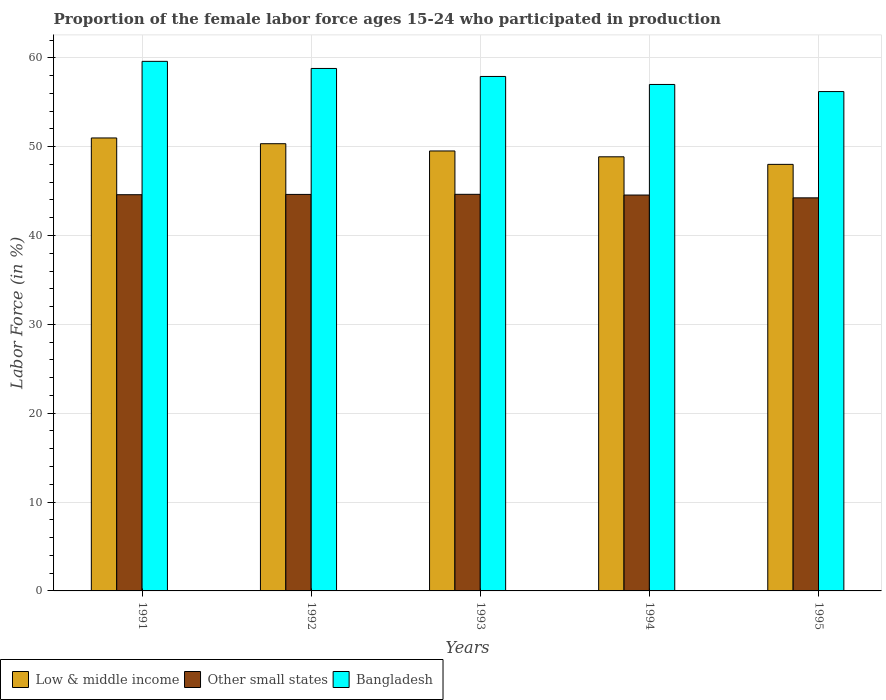How many different coloured bars are there?
Your response must be concise. 3. How many groups of bars are there?
Keep it short and to the point. 5. Are the number of bars per tick equal to the number of legend labels?
Make the answer very short. Yes. What is the label of the 3rd group of bars from the left?
Your response must be concise. 1993. What is the proportion of the female labor force who participated in production in Low & middle income in 1995?
Provide a short and direct response. 48.01. Across all years, what is the maximum proportion of the female labor force who participated in production in Low & middle income?
Provide a short and direct response. 50.98. Across all years, what is the minimum proportion of the female labor force who participated in production in Bangladesh?
Give a very brief answer. 56.2. In which year was the proportion of the female labor force who participated in production in Low & middle income minimum?
Offer a terse response. 1995. What is the total proportion of the female labor force who participated in production in Low & middle income in the graph?
Your answer should be very brief. 247.69. What is the difference between the proportion of the female labor force who participated in production in Low & middle income in 1992 and that in 1995?
Offer a terse response. 2.32. What is the difference between the proportion of the female labor force who participated in production in Other small states in 1993 and the proportion of the female labor force who participated in production in Bangladesh in 1991?
Your answer should be compact. -14.97. What is the average proportion of the female labor force who participated in production in Other small states per year?
Keep it short and to the point. 44.53. In the year 1995, what is the difference between the proportion of the female labor force who participated in production in Bangladesh and proportion of the female labor force who participated in production in Other small states?
Make the answer very short. 11.96. In how many years, is the proportion of the female labor force who participated in production in Bangladesh greater than 12 %?
Give a very brief answer. 5. What is the ratio of the proportion of the female labor force who participated in production in Bangladesh in 1992 to that in 1994?
Your answer should be very brief. 1.03. Is the proportion of the female labor force who participated in production in Other small states in 1992 less than that in 1993?
Your answer should be compact. Yes. Is the difference between the proportion of the female labor force who participated in production in Bangladesh in 1991 and 1995 greater than the difference between the proportion of the female labor force who participated in production in Other small states in 1991 and 1995?
Make the answer very short. Yes. What is the difference between the highest and the second highest proportion of the female labor force who participated in production in Bangladesh?
Provide a succinct answer. 0.8. What is the difference between the highest and the lowest proportion of the female labor force who participated in production in Low & middle income?
Give a very brief answer. 2.97. In how many years, is the proportion of the female labor force who participated in production in Other small states greater than the average proportion of the female labor force who participated in production in Other small states taken over all years?
Offer a terse response. 4. Is the sum of the proportion of the female labor force who participated in production in Low & middle income in 1992 and 1995 greater than the maximum proportion of the female labor force who participated in production in Other small states across all years?
Provide a succinct answer. Yes. Is it the case that in every year, the sum of the proportion of the female labor force who participated in production in Other small states and proportion of the female labor force who participated in production in Bangladesh is greater than the proportion of the female labor force who participated in production in Low & middle income?
Your answer should be compact. Yes. How many years are there in the graph?
Ensure brevity in your answer.  5. What is the difference between two consecutive major ticks on the Y-axis?
Offer a terse response. 10. Does the graph contain any zero values?
Provide a succinct answer. No. Does the graph contain grids?
Provide a succinct answer. Yes. How many legend labels are there?
Provide a short and direct response. 3. What is the title of the graph?
Your answer should be compact. Proportion of the female labor force ages 15-24 who participated in production. Does "Brazil" appear as one of the legend labels in the graph?
Ensure brevity in your answer.  No. What is the Labor Force (in %) in Low & middle income in 1991?
Your answer should be compact. 50.98. What is the Labor Force (in %) in Other small states in 1991?
Offer a very short reply. 44.59. What is the Labor Force (in %) in Bangladesh in 1991?
Give a very brief answer. 59.6. What is the Labor Force (in %) of Low & middle income in 1992?
Your response must be concise. 50.33. What is the Labor Force (in %) in Other small states in 1992?
Your response must be concise. 44.62. What is the Labor Force (in %) of Bangladesh in 1992?
Give a very brief answer. 58.8. What is the Labor Force (in %) in Low & middle income in 1993?
Your answer should be compact. 49.51. What is the Labor Force (in %) in Other small states in 1993?
Your answer should be compact. 44.63. What is the Labor Force (in %) in Bangladesh in 1993?
Offer a very short reply. 57.9. What is the Labor Force (in %) of Low & middle income in 1994?
Give a very brief answer. 48.86. What is the Labor Force (in %) of Other small states in 1994?
Offer a very short reply. 44.55. What is the Labor Force (in %) in Bangladesh in 1994?
Provide a short and direct response. 57. What is the Labor Force (in %) in Low & middle income in 1995?
Provide a short and direct response. 48.01. What is the Labor Force (in %) of Other small states in 1995?
Make the answer very short. 44.24. What is the Labor Force (in %) of Bangladesh in 1995?
Offer a terse response. 56.2. Across all years, what is the maximum Labor Force (in %) of Low & middle income?
Keep it short and to the point. 50.98. Across all years, what is the maximum Labor Force (in %) in Other small states?
Give a very brief answer. 44.63. Across all years, what is the maximum Labor Force (in %) of Bangladesh?
Provide a succinct answer. 59.6. Across all years, what is the minimum Labor Force (in %) of Low & middle income?
Keep it short and to the point. 48.01. Across all years, what is the minimum Labor Force (in %) of Other small states?
Provide a succinct answer. 44.24. Across all years, what is the minimum Labor Force (in %) in Bangladesh?
Ensure brevity in your answer.  56.2. What is the total Labor Force (in %) of Low & middle income in the graph?
Ensure brevity in your answer.  247.69. What is the total Labor Force (in %) of Other small states in the graph?
Your response must be concise. 222.64. What is the total Labor Force (in %) in Bangladesh in the graph?
Give a very brief answer. 289.5. What is the difference between the Labor Force (in %) of Low & middle income in 1991 and that in 1992?
Provide a short and direct response. 0.65. What is the difference between the Labor Force (in %) in Other small states in 1991 and that in 1992?
Give a very brief answer. -0.03. What is the difference between the Labor Force (in %) in Low & middle income in 1991 and that in 1993?
Provide a short and direct response. 1.46. What is the difference between the Labor Force (in %) in Other small states in 1991 and that in 1993?
Make the answer very short. -0.04. What is the difference between the Labor Force (in %) in Low & middle income in 1991 and that in 1994?
Your answer should be compact. 2.12. What is the difference between the Labor Force (in %) of Other small states in 1991 and that in 1994?
Ensure brevity in your answer.  0.04. What is the difference between the Labor Force (in %) of Low & middle income in 1991 and that in 1995?
Your response must be concise. 2.97. What is the difference between the Labor Force (in %) of Other small states in 1991 and that in 1995?
Your response must be concise. 0.35. What is the difference between the Labor Force (in %) of Bangladesh in 1991 and that in 1995?
Keep it short and to the point. 3.4. What is the difference between the Labor Force (in %) of Low & middle income in 1992 and that in 1993?
Your response must be concise. 0.82. What is the difference between the Labor Force (in %) in Other small states in 1992 and that in 1993?
Offer a very short reply. -0.01. What is the difference between the Labor Force (in %) in Low & middle income in 1992 and that in 1994?
Give a very brief answer. 1.47. What is the difference between the Labor Force (in %) in Other small states in 1992 and that in 1994?
Keep it short and to the point. 0.07. What is the difference between the Labor Force (in %) in Bangladesh in 1992 and that in 1994?
Ensure brevity in your answer.  1.8. What is the difference between the Labor Force (in %) in Low & middle income in 1992 and that in 1995?
Offer a very short reply. 2.32. What is the difference between the Labor Force (in %) in Other small states in 1992 and that in 1995?
Offer a very short reply. 0.39. What is the difference between the Labor Force (in %) in Bangladesh in 1992 and that in 1995?
Ensure brevity in your answer.  2.6. What is the difference between the Labor Force (in %) of Low & middle income in 1993 and that in 1994?
Provide a succinct answer. 0.66. What is the difference between the Labor Force (in %) in Other small states in 1993 and that in 1994?
Provide a short and direct response. 0.08. What is the difference between the Labor Force (in %) of Low & middle income in 1993 and that in 1995?
Provide a short and direct response. 1.51. What is the difference between the Labor Force (in %) in Other small states in 1993 and that in 1995?
Keep it short and to the point. 0.4. What is the difference between the Labor Force (in %) of Bangladesh in 1993 and that in 1995?
Offer a very short reply. 1.7. What is the difference between the Labor Force (in %) in Low & middle income in 1994 and that in 1995?
Provide a succinct answer. 0.85. What is the difference between the Labor Force (in %) in Other small states in 1994 and that in 1995?
Make the answer very short. 0.32. What is the difference between the Labor Force (in %) of Low & middle income in 1991 and the Labor Force (in %) of Other small states in 1992?
Give a very brief answer. 6.35. What is the difference between the Labor Force (in %) of Low & middle income in 1991 and the Labor Force (in %) of Bangladesh in 1992?
Offer a terse response. -7.82. What is the difference between the Labor Force (in %) in Other small states in 1991 and the Labor Force (in %) in Bangladesh in 1992?
Offer a terse response. -14.21. What is the difference between the Labor Force (in %) of Low & middle income in 1991 and the Labor Force (in %) of Other small states in 1993?
Offer a terse response. 6.34. What is the difference between the Labor Force (in %) in Low & middle income in 1991 and the Labor Force (in %) in Bangladesh in 1993?
Your response must be concise. -6.92. What is the difference between the Labor Force (in %) of Other small states in 1991 and the Labor Force (in %) of Bangladesh in 1993?
Give a very brief answer. -13.31. What is the difference between the Labor Force (in %) in Low & middle income in 1991 and the Labor Force (in %) in Other small states in 1994?
Your answer should be compact. 6.42. What is the difference between the Labor Force (in %) in Low & middle income in 1991 and the Labor Force (in %) in Bangladesh in 1994?
Your answer should be very brief. -6.02. What is the difference between the Labor Force (in %) of Other small states in 1991 and the Labor Force (in %) of Bangladesh in 1994?
Your answer should be very brief. -12.41. What is the difference between the Labor Force (in %) in Low & middle income in 1991 and the Labor Force (in %) in Other small states in 1995?
Ensure brevity in your answer.  6.74. What is the difference between the Labor Force (in %) of Low & middle income in 1991 and the Labor Force (in %) of Bangladesh in 1995?
Your answer should be compact. -5.22. What is the difference between the Labor Force (in %) in Other small states in 1991 and the Labor Force (in %) in Bangladesh in 1995?
Offer a terse response. -11.61. What is the difference between the Labor Force (in %) in Low & middle income in 1992 and the Labor Force (in %) in Other small states in 1993?
Your response must be concise. 5.7. What is the difference between the Labor Force (in %) of Low & middle income in 1992 and the Labor Force (in %) of Bangladesh in 1993?
Provide a short and direct response. -7.57. What is the difference between the Labor Force (in %) in Other small states in 1992 and the Labor Force (in %) in Bangladesh in 1993?
Make the answer very short. -13.28. What is the difference between the Labor Force (in %) of Low & middle income in 1992 and the Labor Force (in %) of Other small states in 1994?
Provide a succinct answer. 5.78. What is the difference between the Labor Force (in %) of Low & middle income in 1992 and the Labor Force (in %) of Bangladesh in 1994?
Your answer should be very brief. -6.67. What is the difference between the Labor Force (in %) of Other small states in 1992 and the Labor Force (in %) of Bangladesh in 1994?
Your answer should be very brief. -12.38. What is the difference between the Labor Force (in %) of Low & middle income in 1992 and the Labor Force (in %) of Other small states in 1995?
Provide a short and direct response. 6.09. What is the difference between the Labor Force (in %) in Low & middle income in 1992 and the Labor Force (in %) in Bangladesh in 1995?
Offer a very short reply. -5.87. What is the difference between the Labor Force (in %) of Other small states in 1992 and the Labor Force (in %) of Bangladesh in 1995?
Provide a short and direct response. -11.58. What is the difference between the Labor Force (in %) in Low & middle income in 1993 and the Labor Force (in %) in Other small states in 1994?
Offer a terse response. 4.96. What is the difference between the Labor Force (in %) of Low & middle income in 1993 and the Labor Force (in %) of Bangladesh in 1994?
Give a very brief answer. -7.49. What is the difference between the Labor Force (in %) in Other small states in 1993 and the Labor Force (in %) in Bangladesh in 1994?
Your response must be concise. -12.37. What is the difference between the Labor Force (in %) in Low & middle income in 1993 and the Labor Force (in %) in Other small states in 1995?
Provide a short and direct response. 5.28. What is the difference between the Labor Force (in %) of Low & middle income in 1993 and the Labor Force (in %) of Bangladesh in 1995?
Your response must be concise. -6.68. What is the difference between the Labor Force (in %) of Other small states in 1993 and the Labor Force (in %) of Bangladesh in 1995?
Your answer should be compact. -11.57. What is the difference between the Labor Force (in %) of Low & middle income in 1994 and the Labor Force (in %) of Other small states in 1995?
Your answer should be very brief. 4.62. What is the difference between the Labor Force (in %) of Low & middle income in 1994 and the Labor Force (in %) of Bangladesh in 1995?
Offer a very short reply. -7.34. What is the difference between the Labor Force (in %) in Other small states in 1994 and the Labor Force (in %) in Bangladesh in 1995?
Your response must be concise. -11.65. What is the average Labor Force (in %) in Low & middle income per year?
Make the answer very short. 49.54. What is the average Labor Force (in %) in Other small states per year?
Give a very brief answer. 44.53. What is the average Labor Force (in %) of Bangladesh per year?
Provide a short and direct response. 57.9. In the year 1991, what is the difference between the Labor Force (in %) of Low & middle income and Labor Force (in %) of Other small states?
Make the answer very short. 6.39. In the year 1991, what is the difference between the Labor Force (in %) of Low & middle income and Labor Force (in %) of Bangladesh?
Your answer should be compact. -8.62. In the year 1991, what is the difference between the Labor Force (in %) in Other small states and Labor Force (in %) in Bangladesh?
Give a very brief answer. -15.01. In the year 1992, what is the difference between the Labor Force (in %) of Low & middle income and Labor Force (in %) of Other small states?
Your response must be concise. 5.71. In the year 1992, what is the difference between the Labor Force (in %) of Low & middle income and Labor Force (in %) of Bangladesh?
Provide a short and direct response. -8.47. In the year 1992, what is the difference between the Labor Force (in %) of Other small states and Labor Force (in %) of Bangladesh?
Ensure brevity in your answer.  -14.18. In the year 1993, what is the difference between the Labor Force (in %) of Low & middle income and Labor Force (in %) of Other small states?
Your response must be concise. 4.88. In the year 1993, what is the difference between the Labor Force (in %) of Low & middle income and Labor Force (in %) of Bangladesh?
Provide a short and direct response. -8.38. In the year 1993, what is the difference between the Labor Force (in %) of Other small states and Labor Force (in %) of Bangladesh?
Make the answer very short. -13.27. In the year 1994, what is the difference between the Labor Force (in %) in Low & middle income and Labor Force (in %) in Other small states?
Offer a terse response. 4.3. In the year 1994, what is the difference between the Labor Force (in %) of Low & middle income and Labor Force (in %) of Bangladesh?
Offer a terse response. -8.14. In the year 1994, what is the difference between the Labor Force (in %) of Other small states and Labor Force (in %) of Bangladesh?
Your response must be concise. -12.45. In the year 1995, what is the difference between the Labor Force (in %) of Low & middle income and Labor Force (in %) of Other small states?
Your response must be concise. 3.77. In the year 1995, what is the difference between the Labor Force (in %) in Low & middle income and Labor Force (in %) in Bangladesh?
Your answer should be compact. -8.19. In the year 1995, what is the difference between the Labor Force (in %) in Other small states and Labor Force (in %) in Bangladesh?
Provide a short and direct response. -11.96. What is the ratio of the Labor Force (in %) in Low & middle income in 1991 to that in 1992?
Offer a terse response. 1.01. What is the ratio of the Labor Force (in %) in Bangladesh in 1991 to that in 1992?
Offer a terse response. 1.01. What is the ratio of the Labor Force (in %) of Low & middle income in 1991 to that in 1993?
Make the answer very short. 1.03. What is the ratio of the Labor Force (in %) in Bangladesh in 1991 to that in 1993?
Give a very brief answer. 1.03. What is the ratio of the Labor Force (in %) in Low & middle income in 1991 to that in 1994?
Offer a very short reply. 1.04. What is the ratio of the Labor Force (in %) in Other small states in 1991 to that in 1994?
Give a very brief answer. 1. What is the ratio of the Labor Force (in %) of Bangladesh in 1991 to that in 1994?
Offer a very short reply. 1.05. What is the ratio of the Labor Force (in %) of Low & middle income in 1991 to that in 1995?
Your answer should be compact. 1.06. What is the ratio of the Labor Force (in %) of Other small states in 1991 to that in 1995?
Ensure brevity in your answer.  1.01. What is the ratio of the Labor Force (in %) of Bangladesh in 1991 to that in 1995?
Provide a succinct answer. 1.06. What is the ratio of the Labor Force (in %) in Low & middle income in 1992 to that in 1993?
Give a very brief answer. 1.02. What is the ratio of the Labor Force (in %) in Other small states in 1992 to that in 1993?
Offer a very short reply. 1. What is the ratio of the Labor Force (in %) in Bangladesh in 1992 to that in 1993?
Your response must be concise. 1.02. What is the ratio of the Labor Force (in %) in Low & middle income in 1992 to that in 1994?
Offer a terse response. 1.03. What is the ratio of the Labor Force (in %) of Bangladesh in 1992 to that in 1994?
Your response must be concise. 1.03. What is the ratio of the Labor Force (in %) of Low & middle income in 1992 to that in 1995?
Your answer should be compact. 1.05. What is the ratio of the Labor Force (in %) in Other small states in 1992 to that in 1995?
Make the answer very short. 1.01. What is the ratio of the Labor Force (in %) of Bangladesh in 1992 to that in 1995?
Your answer should be very brief. 1.05. What is the ratio of the Labor Force (in %) of Low & middle income in 1993 to that in 1994?
Make the answer very short. 1.01. What is the ratio of the Labor Force (in %) in Bangladesh in 1993 to that in 1994?
Give a very brief answer. 1.02. What is the ratio of the Labor Force (in %) in Low & middle income in 1993 to that in 1995?
Offer a terse response. 1.03. What is the ratio of the Labor Force (in %) of Other small states in 1993 to that in 1995?
Keep it short and to the point. 1.01. What is the ratio of the Labor Force (in %) of Bangladesh in 1993 to that in 1995?
Provide a short and direct response. 1.03. What is the ratio of the Labor Force (in %) of Low & middle income in 1994 to that in 1995?
Your response must be concise. 1.02. What is the ratio of the Labor Force (in %) of Bangladesh in 1994 to that in 1995?
Provide a succinct answer. 1.01. What is the difference between the highest and the second highest Labor Force (in %) in Low & middle income?
Keep it short and to the point. 0.65. What is the difference between the highest and the second highest Labor Force (in %) in Other small states?
Offer a very short reply. 0.01. What is the difference between the highest and the second highest Labor Force (in %) in Bangladesh?
Give a very brief answer. 0.8. What is the difference between the highest and the lowest Labor Force (in %) in Low & middle income?
Offer a terse response. 2.97. What is the difference between the highest and the lowest Labor Force (in %) in Other small states?
Provide a succinct answer. 0.4. 